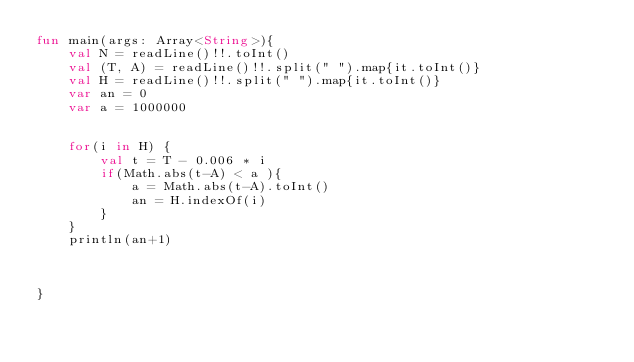Convert code to text. <code><loc_0><loc_0><loc_500><loc_500><_Kotlin_>fun main(args: Array<String>){
    val N = readLine()!!.toInt()
    val (T, A) = readLine()!!.split(" ").map{it.toInt()}
    val H = readLine()!!.split(" ").map{it.toInt()}
    var an = 0
    var a = 1000000


    for(i in H) {
        val t = T - 0.006 * i
        if(Math.abs(t-A) < a ){
            a = Math.abs(t-A).toInt()
            an = H.indexOf(i)
        }
    }
    println(an+1)



}</code> 